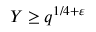<formula> <loc_0><loc_0><loc_500><loc_500>Y \geq q ^ { 1 / 4 + \varepsilon }</formula> 